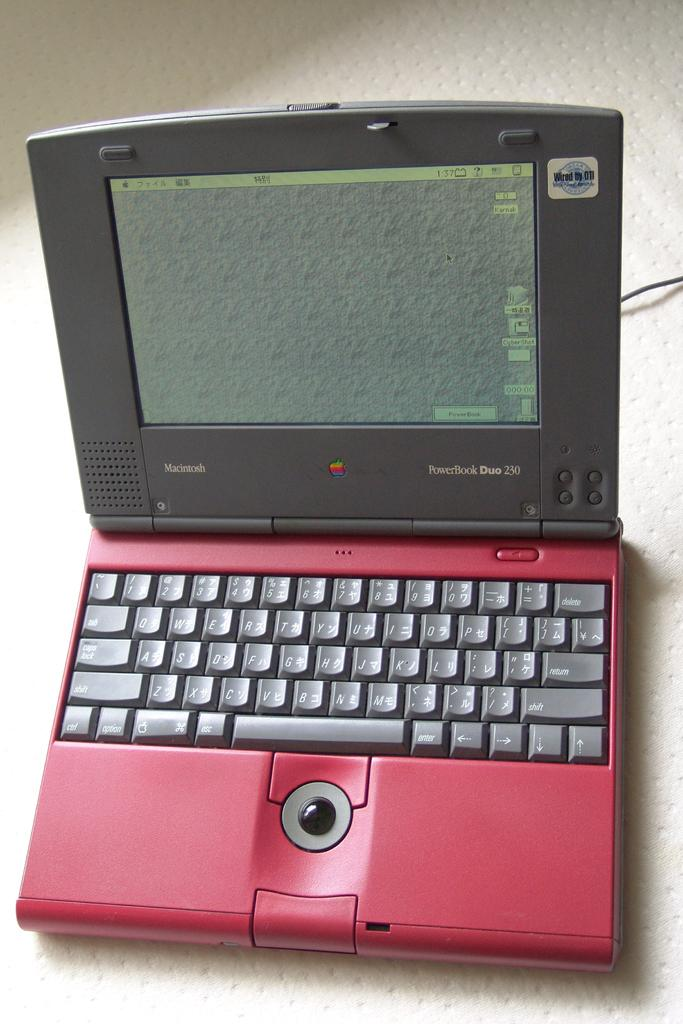Provide a one-sentence caption for the provided image. Red and black laptop that is "Wired by DTI". 